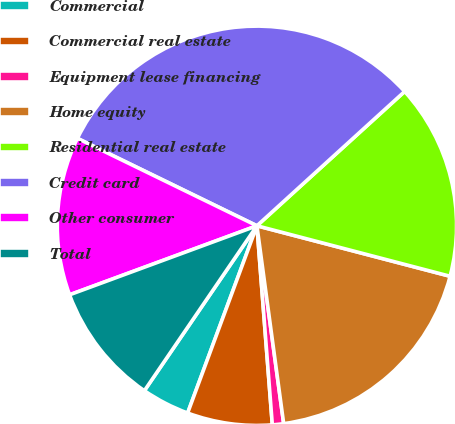<chart> <loc_0><loc_0><loc_500><loc_500><pie_chart><fcel>Commercial<fcel>Commercial real estate<fcel>Equipment lease financing<fcel>Home equity<fcel>Residential real estate<fcel>Credit card<fcel>Other consumer<fcel>Total<nl><fcel>3.89%<fcel>6.87%<fcel>0.91%<fcel>18.79%<fcel>15.81%<fcel>31.04%<fcel>12.83%<fcel>9.85%<nl></chart> 